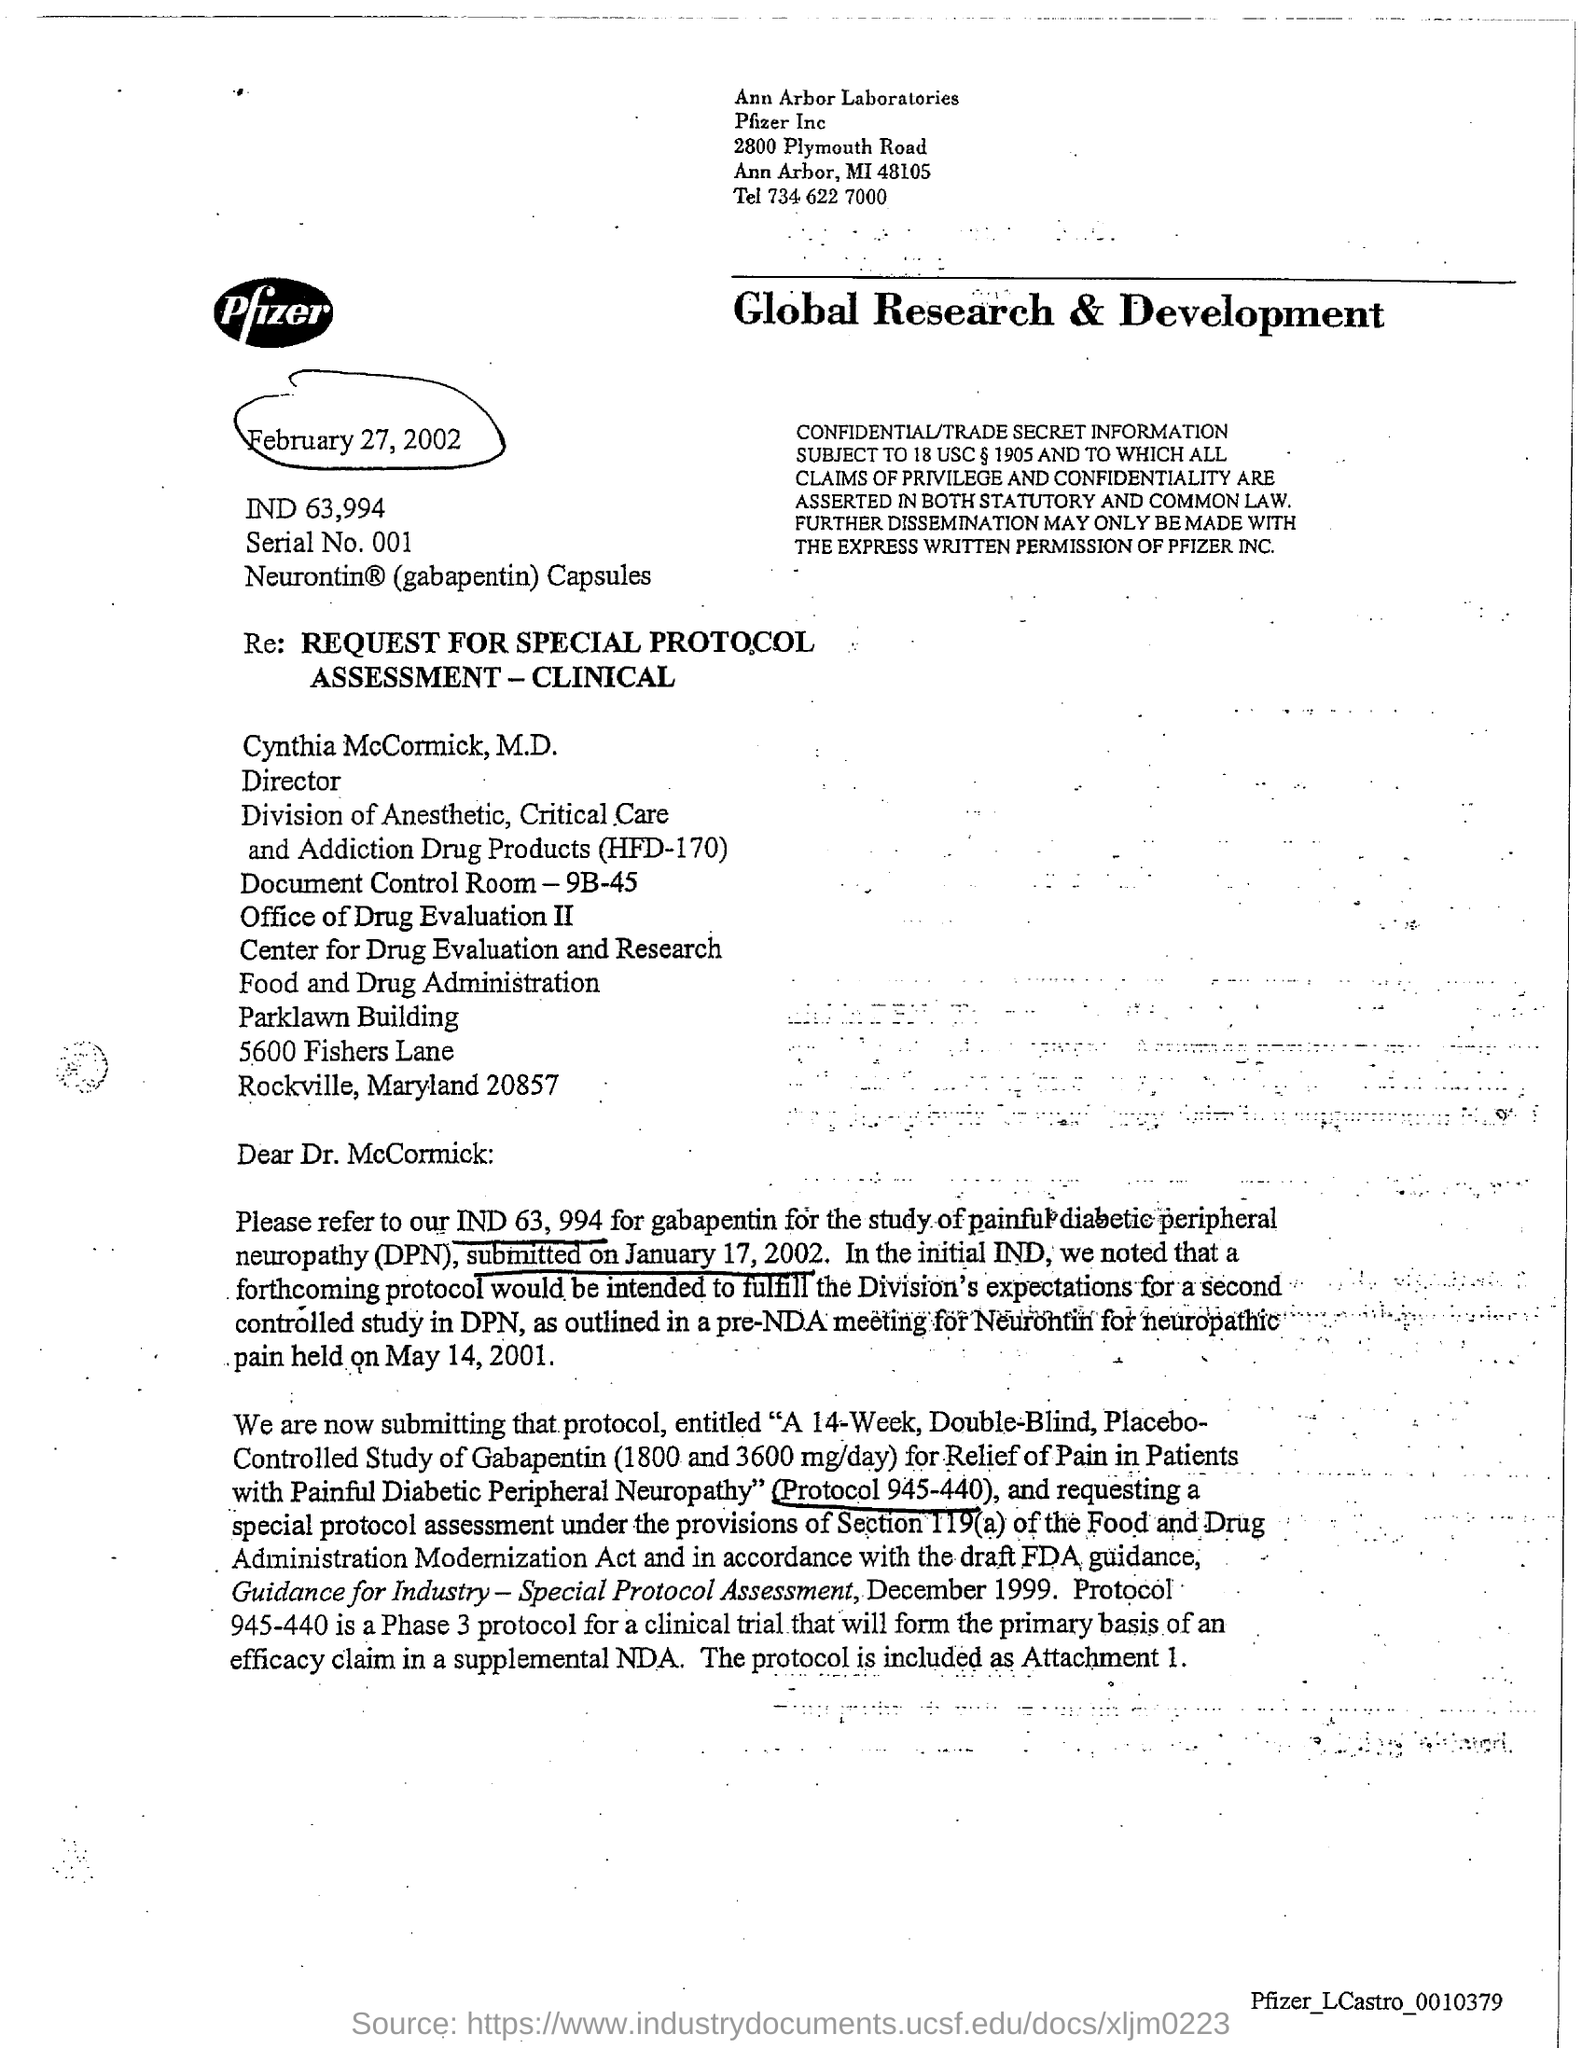What is Serial No.?
Ensure brevity in your answer.  001. 